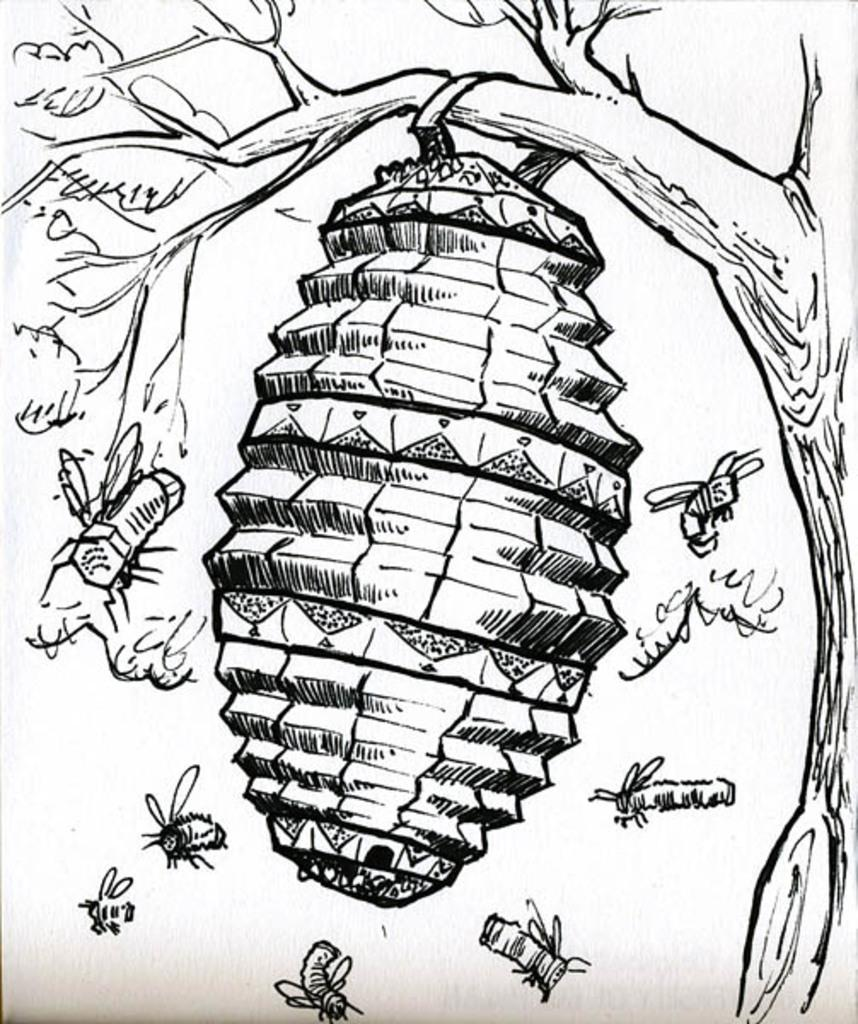What type of art is featured in the image? The image contains pencil art. What is the subject of the pencil art? The art depicts a tree. What is hanging from the tree in the image? There is a honeycomb hanging from the tree. What is happening around the tree and honeycomb in the image? Bees are flying around the tree and honeycomb. What type of map can be seen in the image? There is no map present in the image; it features pencil art of a tree with a honeycomb and bees. What type of current is flowing through the balls in the image? There are no balls or current present in the image. 